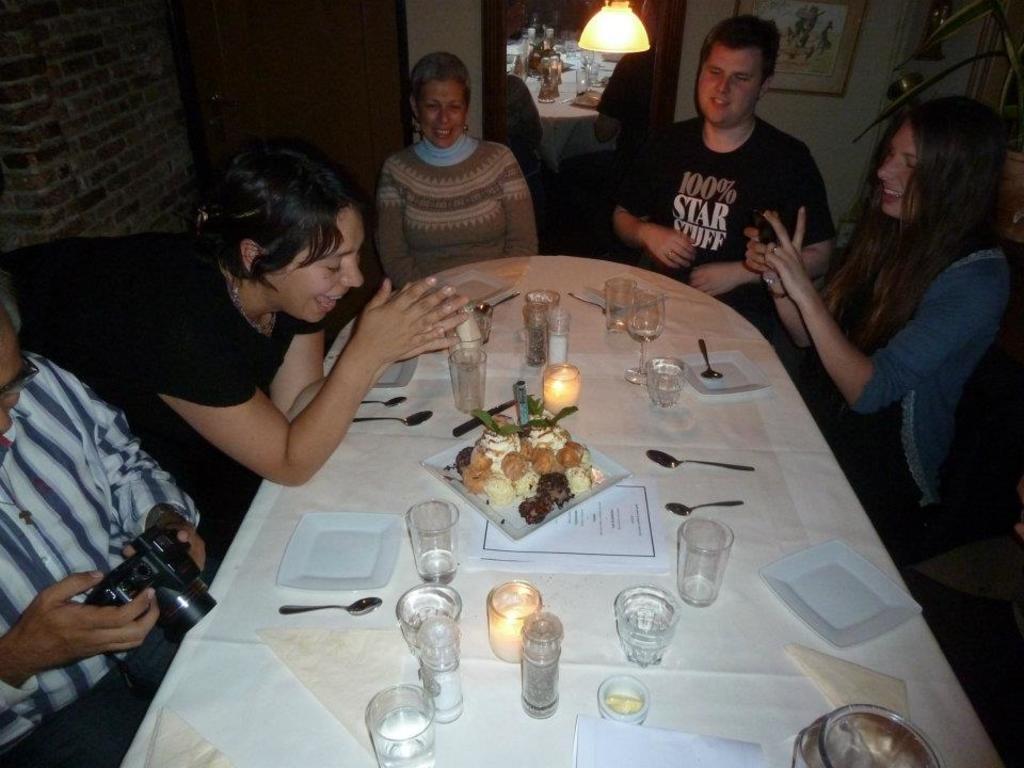In one or two sentences, can you explain what this image depicts? In the picture we can see some people are sitting on the chairs near the table. On the table we can find a white cloth some glasses, papers, food and candle. In the background we can find two doors, brick wall, photo frames and to the ceiling there is a light. 